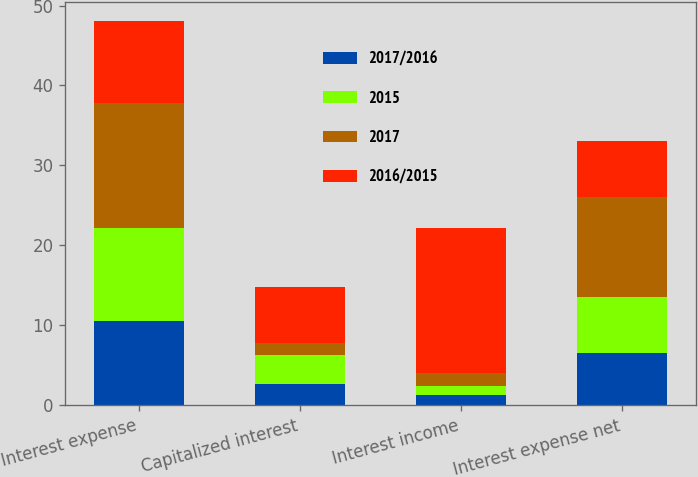Convert chart. <chart><loc_0><loc_0><loc_500><loc_500><stacked_bar_chart><ecel><fcel>Interest expense<fcel>Capitalized interest<fcel>Interest income<fcel>Interest expense net<nl><fcel>2017/2016<fcel>10.5<fcel>2.7<fcel>1.3<fcel>6.5<nl><fcel>2015<fcel>11.7<fcel>3.6<fcel>1.1<fcel>7<nl><fcel>2017<fcel>15.6<fcel>1.5<fcel>1.6<fcel>12.5<nl><fcel>2016/2015<fcel>10.3<fcel>7<fcel>18.2<fcel>7.1<nl></chart> 